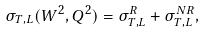Convert formula to latex. <formula><loc_0><loc_0><loc_500><loc_500>\sigma _ { T , L } ( W ^ { 2 } , Q ^ { 2 } ) = \sigma ^ { R } _ { T , L } + \sigma ^ { N R } _ { T , L } ,</formula> 